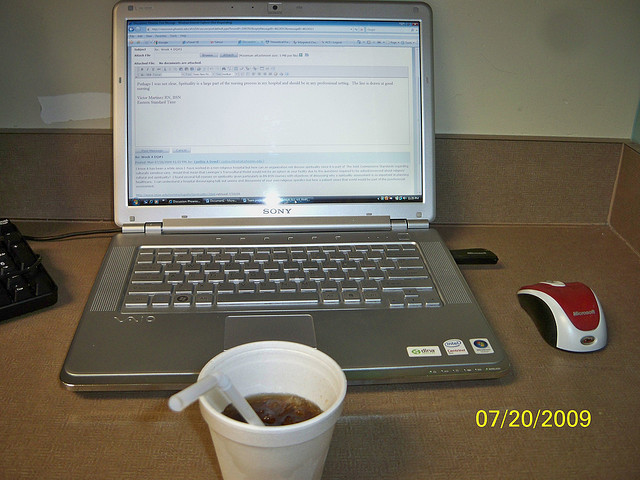Identify the text displayed in this image. SONY 2009 /20 07 